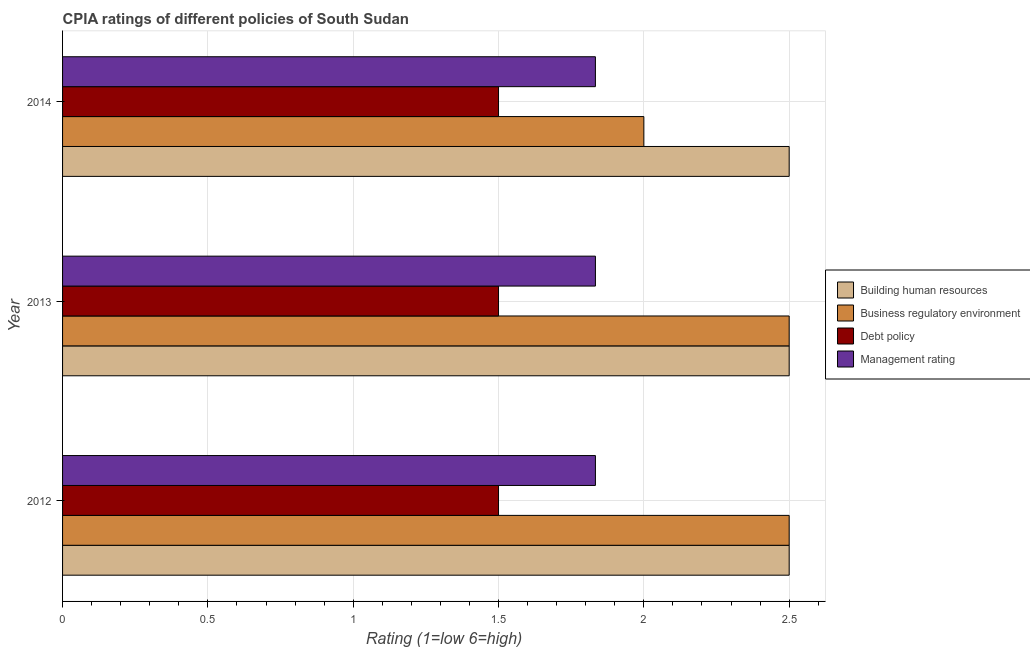How many different coloured bars are there?
Give a very brief answer. 4. How many groups of bars are there?
Offer a very short reply. 3. How many bars are there on the 3rd tick from the top?
Make the answer very short. 4. How many bars are there on the 2nd tick from the bottom?
Keep it short and to the point. 4. What is the label of the 2nd group of bars from the top?
Offer a very short reply. 2013. What is the cpia rating of management in 2013?
Your response must be concise. 1.83. In which year was the cpia rating of management maximum?
Give a very brief answer. 2012. In which year was the cpia rating of management minimum?
Offer a very short reply. 2014. What is the total cpia rating of business regulatory environment in the graph?
Provide a short and direct response. 7. What is the difference between the cpia rating of management in 2013 and the cpia rating of debt policy in 2012?
Make the answer very short. 0.33. In the year 2014, what is the difference between the cpia rating of management and cpia rating of building human resources?
Provide a short and direct response. -0.67. In how many years, is the cpia rating of debt policy greater than 0.7 ?
Give a very brief answer. 3. Is the cpia rating of building human resources in 2013 less than that in 2014?
Offer a terse response. No. Is the difference between the cpia rating of debt policy in 2013 and 2014 greater than the difference between the cpia rating of building human resources in 2013 and 2014?
Offer a very short reply. No. Is the sum of the cpia rating of business regulatory environment in 2012 and 2013 greater than the maximum cpia rating of building human resources across all years?
Ensure brevity in your answer.  Yes. Is it the case that in every year, the sum of the cpia rating of debt policy and cpia rating of management is greater than the sum of cpia rating of business regulatory environment and cpia rating of building human resources?
Your response must be concise. No. What does the 2nd bar from the top in 2012 represents?
Your answer should be compact. Debt policy. What does the 1st bar from the bottom in 2014 represents?
Provide a short and direct response. Building human resources. How many bars are there?
Provide a succinct answer. 12. Are the values on the major ticks of X-axis written in scientific E-notation?
Your answer should be very brief. No. How many legend labels are there?
Your answer should be very brief. 4. How are the legend labels stacked?
Your response must be concise. Vertical. What is the title of the graph?
Make the answer very short. CPIA ratings of different policies of South Sudan. What is the Rating (1=low 6=high) in Building human resources in 2012?
Your answer should be very brief. 2.5. What is the Rating (1=low 6=high) in Business regulatory environment in 2012?
Give a very brief answer. 2.5. What is the Rating (1=low 6=high) of Management rating in 2012?
Offer a very short reply. 1.83. What is the Rating (1=low 6=high) of Business regulatory environment in 2013?
Make the answer very short. 2.5. What is the Rating (1=low 6=high) in Management rating in 2013?
Give a very brief answer. 1.83. What is the Rating (1=low 6=high) in Building human resources in 2014?
Provide a succinct answer. 2.5. What is the Rating (1=low 6=high) in Business regulatory environment in 2014?
Give a very brief answer. 2. What is the Rating (1=low 6=high) of Management rating in 2014?
Provide a short and direct response. 1.83. Across all years, what is the maximum Rating (1=low 6=high) of Debt policy?
Offer a very short reply. 1.5. Across all years, what is the maximum Rating (1=low 6=high) in Management rating?
Offer a terse response. 1.83. Across all years, what is the minimum Rating (1=low 6=high) in Building human resources?
Offer a terse response. 2.5. Across all years, what is the minimum Rating (1=low 6=high) in Debt policy?
Give a very brief answer. 1.5. Across all years, what is the minimum Rating (1=low 6=high) of Management rating?
Keep it short and to the point. 1.83. What is the total Rating (1=low 6=high) of Building human resources in the graph?
Your answer should be compact. 7.5. What is the total Rating (1=low 6=high) of Management rating in the graph?
Offer a very short reply. 5.5. What is the difference between the Rating (1=low 6=high) of Management rating in 2012 and that in 2013?
Give a very brief answer. 0. What is the difference between the Rating (1=low 6=high) in Debt policy in 2012 and that in 2014?
Give a very brief answer. 0. What is the difference between the Rating (1=low 6=high) in Building human resources in 2013 and that in 2014?
Your answer should be very brief. 0. What is the difference between the Rating (1=low 6=high) in Debt policy in 2013 and that in 2014?
Make the answer very short. 0. What is the difference between the Rating (1=low 6=high) of Management rating in 2013 and that in 2014?
Offer a terse response. 0. What is the difference between the Rating (1=low 6=high) in Building human resources in 2012 and the Rating (1=low 6=high) in Management rating in 2013?
Provide a short and direct response. 0.67. What is the difference between the Rating (1=low 6=high) of Building human resources in 2012 and the Rating (1=low 6=high) of Management rating in 2014?
Offer a terse response. 0.67. What is the difference between the Rating (1=low 6=high) of Business regulatory environment in 2012 and the Rating (1=low 6=high) of Management rating in 2014?
Keep it short and to the point. 0.67. What is the difference between the Rating (1=low 6=high) in Building human resources in 2013 and the Rating (1=low 6=high) in Management rating in 2014?
Provide a succinct answer. 0.67. What is the difference between the Rating (1=low 6=high) of Business regulatory environment in 2013 and the Rating (1=low 6=high) of Debt policy in 2014?
Offer a very short reply. 1. What is the difference between the Rating (1=low 6=high) of Business regulatory environment in 2013 and the Rating (1=low 6=high) of Management rating in 2014?
Give a very brief answer. 0.67. What is the average Rating (1=low 6=high) of Building human resources per year?
Keep it short and to the point. 2.5. What is the average Rating (1=low 6=high) in Business regulatory environment per year?
Ensure brevity in your answer.  2.33. What is the average Rating (1=low 6=high) in Debt policy per year?
Offer a terse response. 1.5. What is the average Rating (1=low 6=high) of Management rating per year?
Offer a very short reply. 1.83. In the year 2012, what is the difference between the Rating (1=low 6=high) of Building human resources and Rating (1=low 6=high) of Business regulatory environment?
Offer a very short reply. 0. In the year 2012, what is the difference between the Rating (1=low 6=high) of Building human resources and Rating (1=low 6=high) of Debt policy?
Give a very brief answer. 1. In the year 2012, what is the difference between the Rating (1=low 6=high) in Building human resources and Rating (1=low 6=high) in Management rating?
Keep it short and to the point. 0.67. In the year 2012, what is the difference between the Rating (1=low 6=high) of Business regulatory environment and Rating (1=low 6=high) of Management rating?
Your answer should be compact. 0.67. In the year 2013, what is the difference between the Rating (1=low 6=high) in Building human resources and Rating (1=low 6=high) in Management rating?
Offer a very short reply. 0.67. In the year 2013, what is the difference between the Rating (1=low 6=high) in Business regulatory environment and Rating (1=low 6=high) in Debt policy?
Provide a succinct answer. 1. In the year 2013, what is the difference between the Rating (1=low 6=high) of Business regulatory environment and Rating (1=low 6=high) of Management rating?
Provide a short and direct response. 0.67. In the year 2014, what is the difference between the Rating (1=low 6=high) of Building human resources and Rating (1=low 6=high) of Management rating?
Give a very brief answer. 0.67. In the year 2014, what is the difference between the Rating (1=low 6=high) of Business regulatory environment and Rating (1=low 6=high) of Debt policy?
Offer a very short reply. 0.5. In the year 2014, what is the difference between the Rating (1=low 6=high) of Business regulatory environment and Rating (1=low 6=high) of Management rating?
Keep it short and to the point. 0.17. What is the ratio of the Rating (1=low 6=high) of Building human resources in 2012 to that in 2013?
Provide a short and direct response. 1. What is the ratio of the Rating (1=low 6=high) of Business regulatory environment in 2012 to that in 2013?
Offer a terse response. 1. What is the ratio of the Rating (1=low 6=high) in Debt policy in 2012 to that in 2013?
Provide a short and direct response. 1. What is the ratio of the Rating (1=low 6=high) of Management rating in 2012 to that in 2013?
Provide a succinct answer. 1. What is the ratio of the Rating (1=low 6=high) of Building human resources in 2012 to that in 2014?
Your response must be concise. 1. What is the ratio of the Rating (1=low 6=high) of Business regulatory environment in 2012 to that in 2014?
Offer a terse response. 1.25. What is the ratio of the Rating (1=low 6=high) of Management rating in 2012 to that in 2014?
Keep it short and to the point. 1. What is the ratio of the Rating (1=low 6=high) of Building human resources in 2013 to that in 2014?
Offer a terse response. 1. What is the ratio of the Rating (1=low 6=high) in Business regulatory environment in 2013 to that in 2014?
Your response must be concise. 1.25. What is the ratio of the Rating (1=low 6=high) of Management rating in 2013 to that in 2014?
Offer a terse response. 1. What is the difference between the highest and the lowest Rating (1=low 6=high) in Building human resources?
Offer a very short reply. 0. What is the difference between the highest and the lowest Rating (1=low 6=high) of Business regulatory environment?
Give a very brief answer. 0.5. What is the difference between the highest and the lowest Rating (1=low 6=high) in Management rating?
Ensure brevity in your answer.  0. 